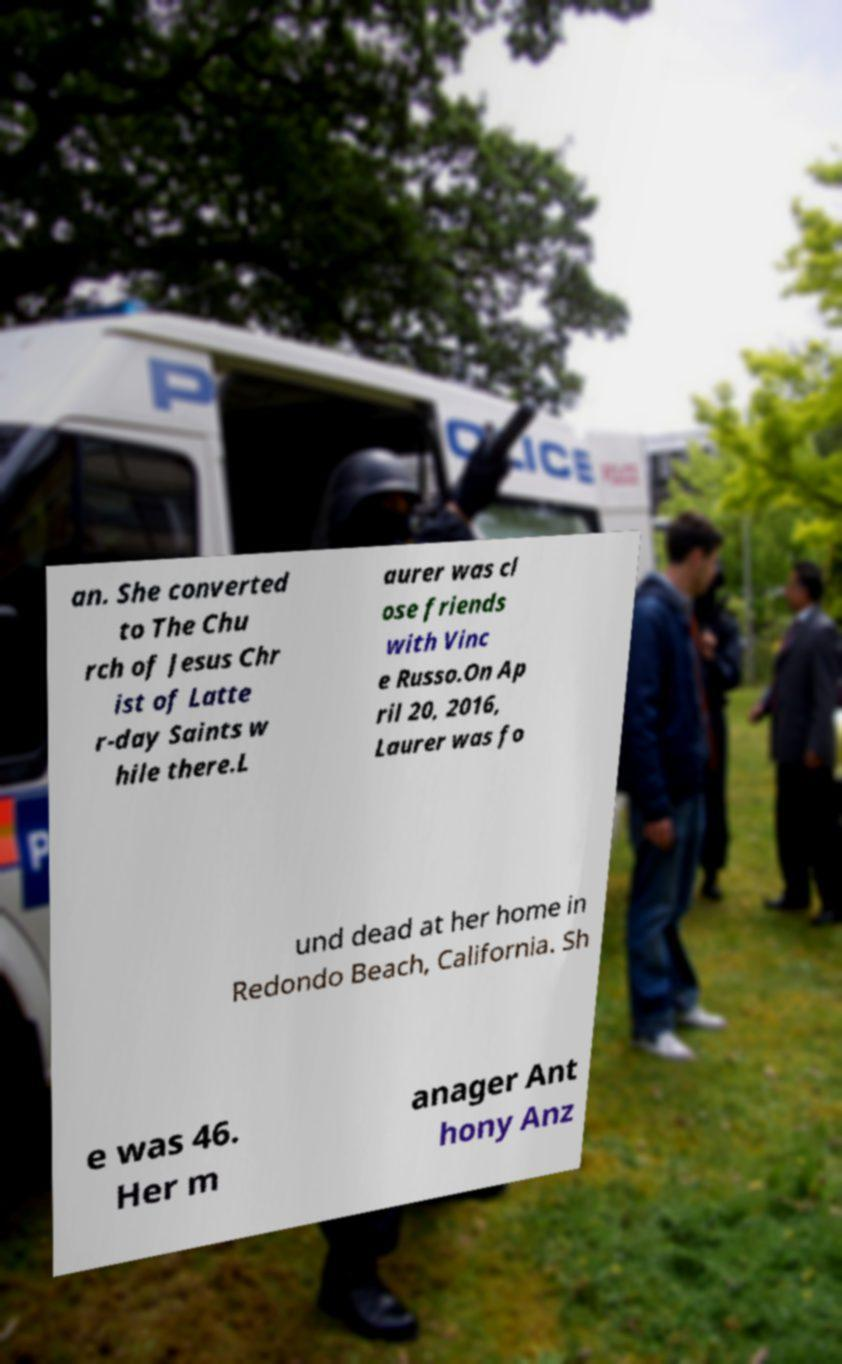Could you assist in decoding the text presented in this image and type it out clearly? an. She converted to The Chu rch of Jesus Chr ist of Latte r-day Saints w hile there.L aurer was cl ose friends with Vinc e Russo.On Ap ril 20, 2016, Laurer was fo und dead at her home in Redondo Beach, California. Sh e was 46. Her m anager Ant hony Anz 